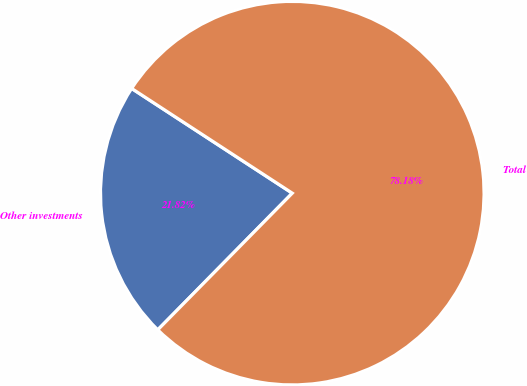Convert chart to OTSL. <chart><loc_0><loc_0><loc_500><loc_500><pie_chart><fcel>Other investments<fcel>Total<nl><fcel>21.82%<fcel>78.18%<nl></chart> 